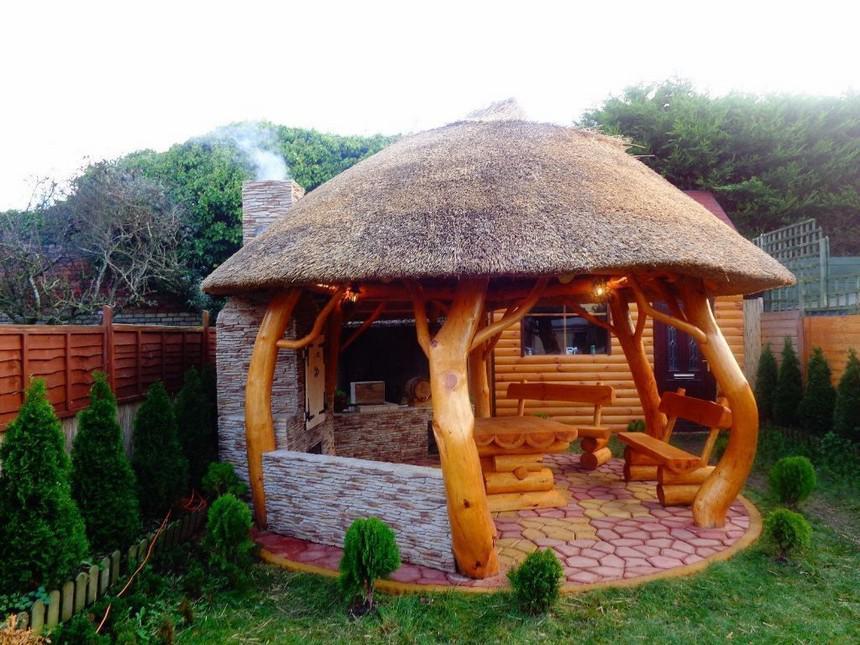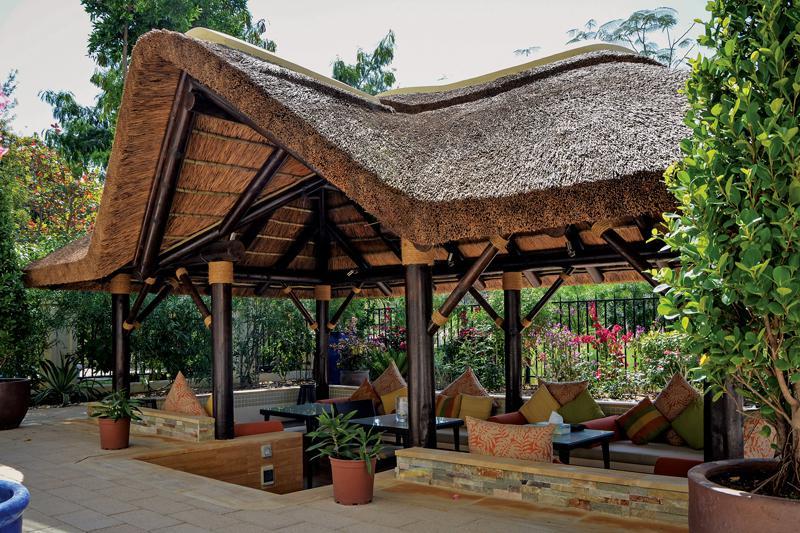The first image is the image on the left, the second image is the image on the right. Examine the images to the left and right. Is the description "The combined images include a two-story structure with wood rails on it and multiple tiered round thatched roofs." accurate? Answer yes or no. No. 